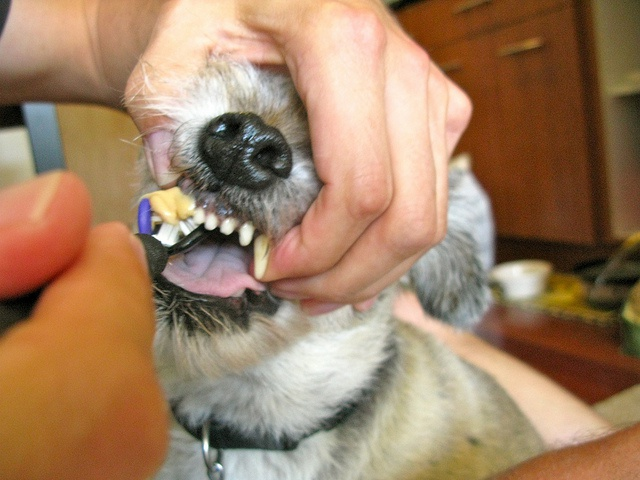Describe the objects in this image and their specific colors. I can see dog in black, darkgray, lightgray, and gray tones, people in black, tan, and ivory tones, toothbrush in black, white, and gray tones, and bowl in black, lightgray, darkgray, and tan tones in this image. 